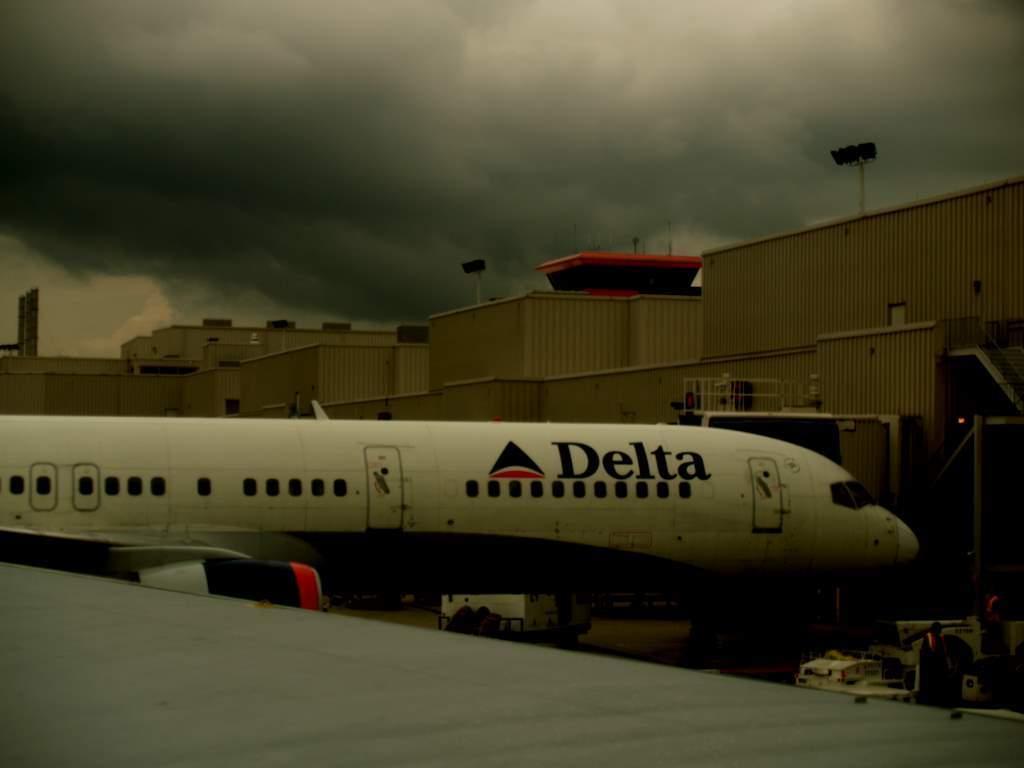Describe this image in one or two sentences. There is an airplane in the middle of this image. We can see shelters in the background and the cloudy sky is at the top of this image. We can see vehicles at the bottom of this image. 